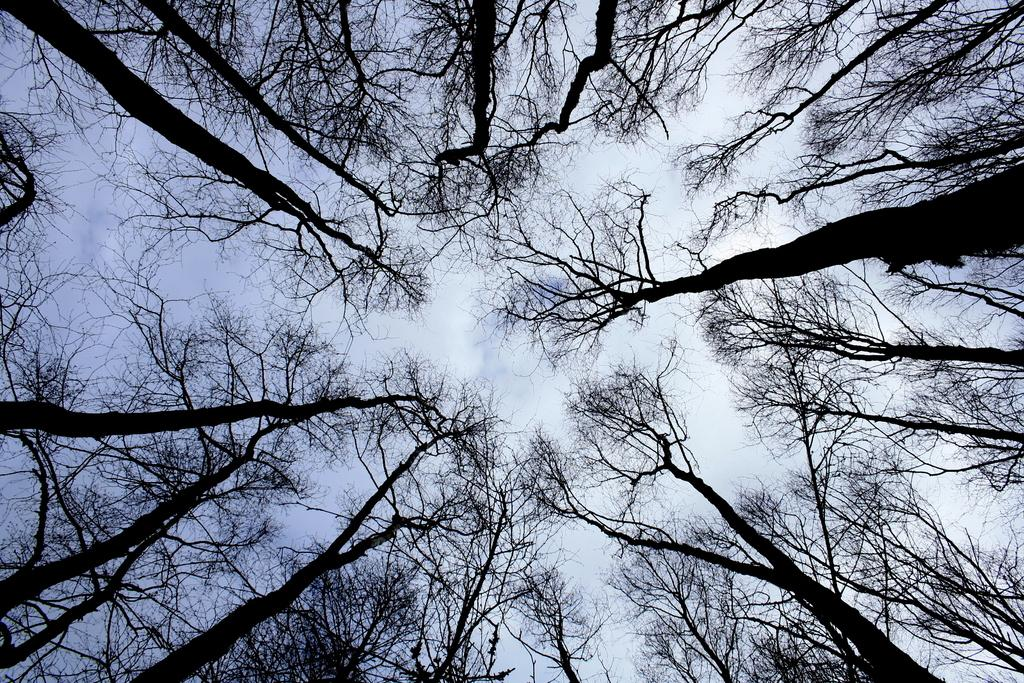What type of vegetation is present in the image? There are dried trees in the image. What colors can be seen in the sky in the image? The sky in the image has white and blue colors. What type of chalk can be seen on the ground in the image? There is no chalk present in the image. How much does the light in the image weigh? The concept of a light having a weight is not applicable, as lights do not have a physical weight. 